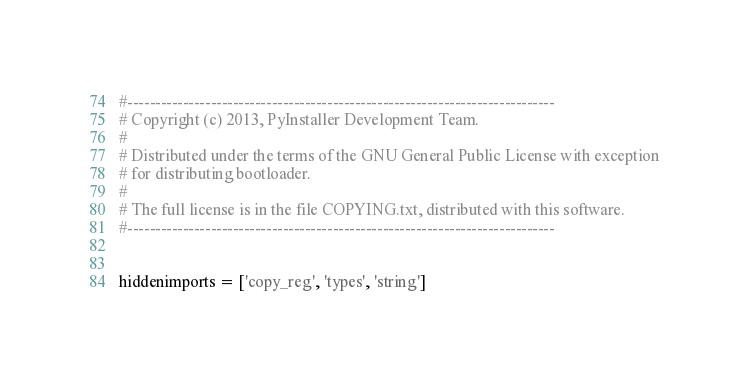Convert code to text. <code><loc_0><loc_0><loc_500><loc_500><_Python_>#-----------------------------------------------------------------------------
# Copyright (c) 2013, PyInstaller Development Team.
#
# Distributed under the terms of the GNU General Public License with exception
# for distributing bootloader.
#
# The full license is in the file COPYING.txt, distributed with this software.
#-----------------------------------------------------------------------------


hiddenimports = ['copy_reg', 'types', 'string']
</code> 